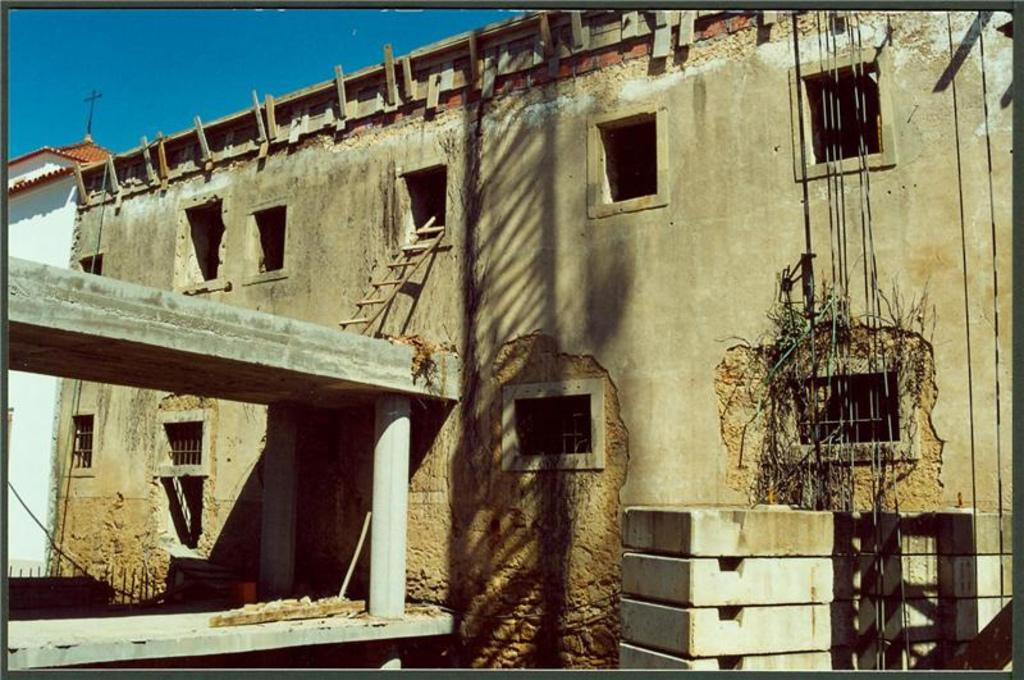What is the main subject of the image? The main subject of the image is a partially constructed building. What can be seen in the foreground of the image? Cement bricks are present in the foreground of the image. What type of light can be seen shining through the windows of the building in the image? There are no windows visible in the image, and therefore no light shining through them. How is the salt being used in the construction process in the image? There is no salt present in the image, and it is not being used in the construction process. 